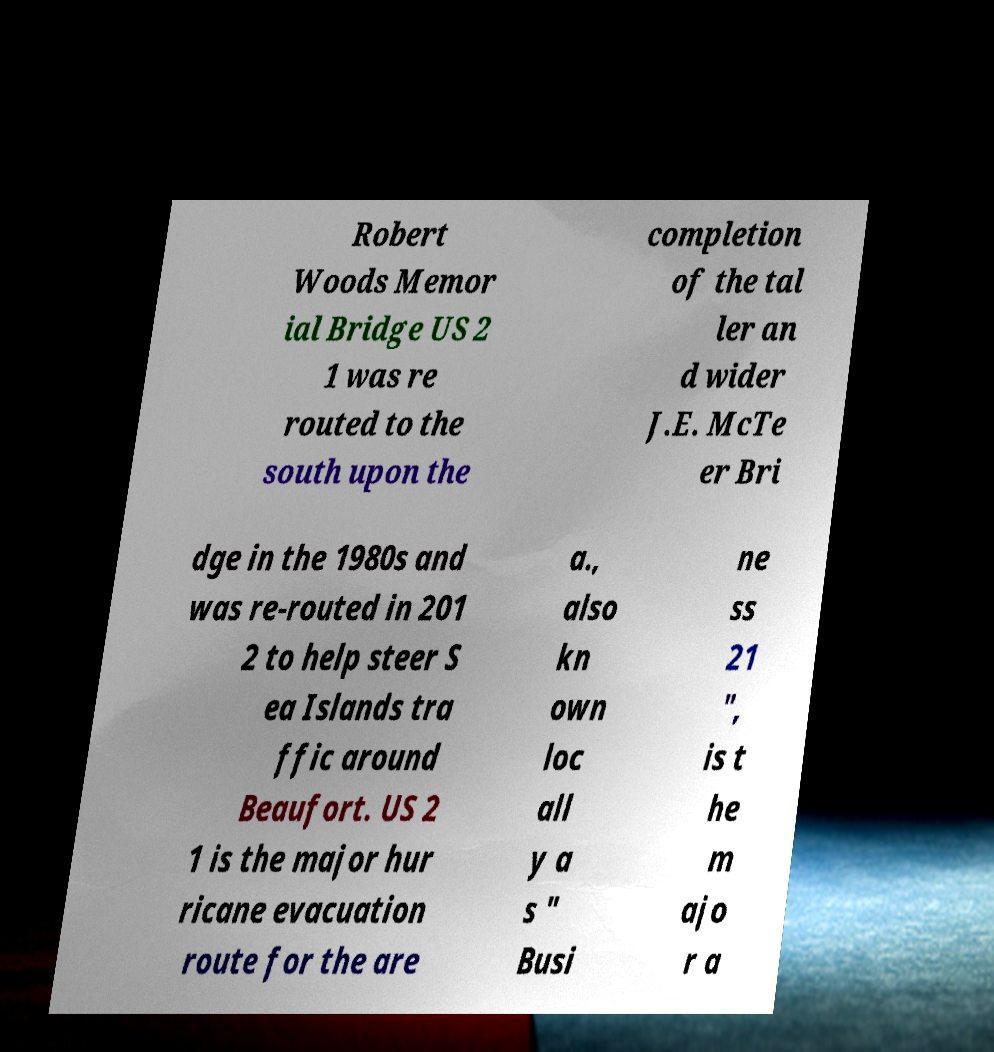There's text embedded in this image that I need extracted. Can you transcribe it verbatim? Robert Woods Memor ial Bridge US 2 1 was re routed to the south upon the completion of the tal ler an d wider J.E. McTe er Bri dge in the 1980s and was re-routed in 201 2 to help steer S ea Islands tra ffic around Beaufort. US 2 1 is the major hur ricane evacuation route for the are a., also kn own loc all y a s " Busi ne ss 21 ", is t he m ajo r a 